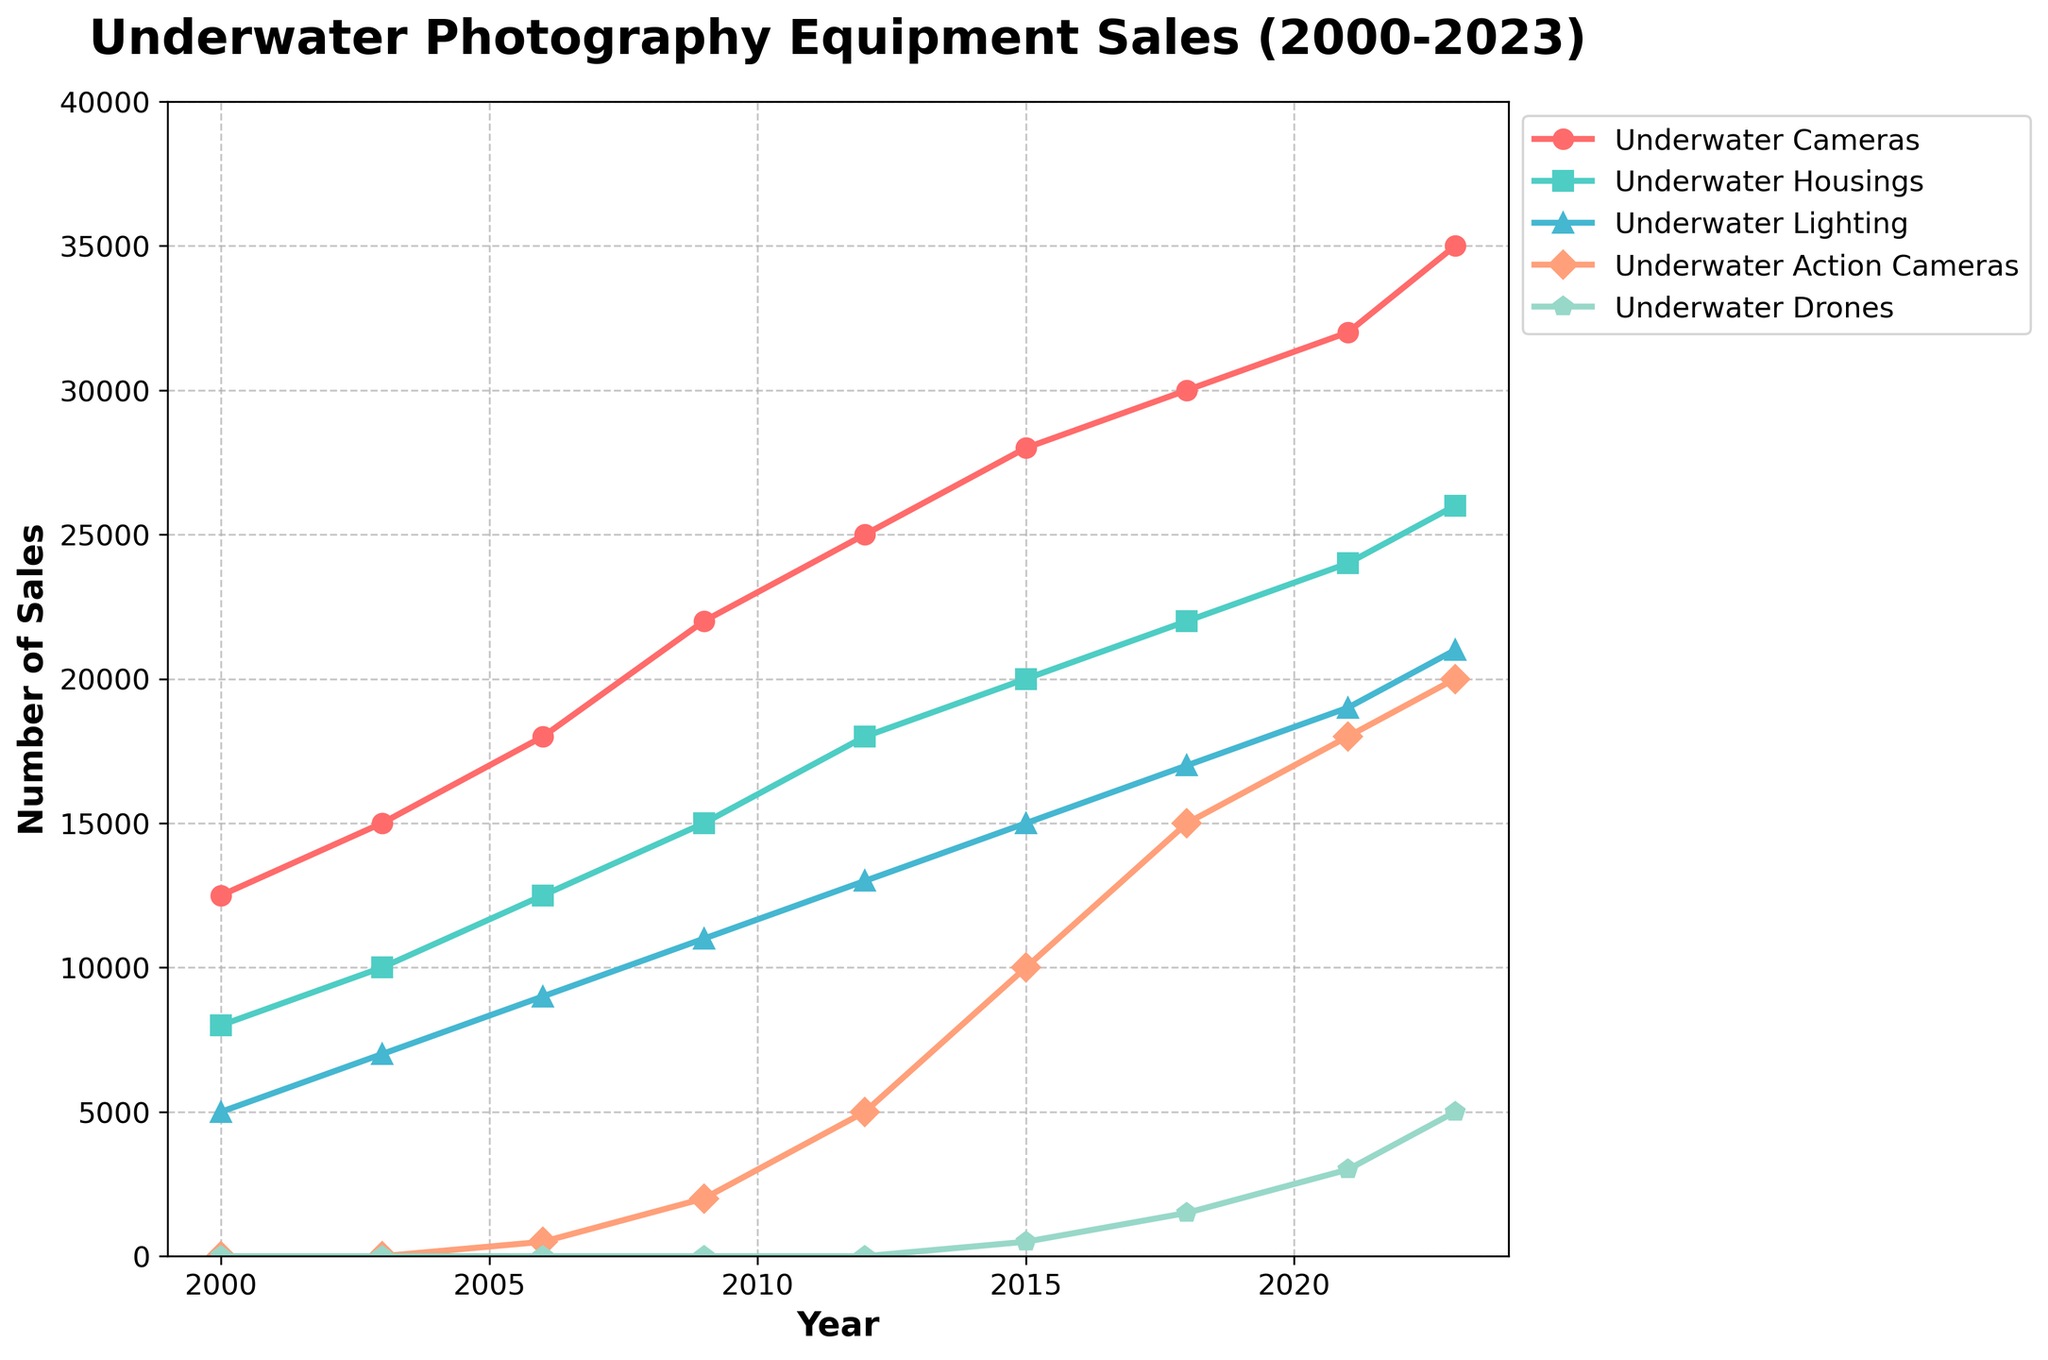What was the total number of underwater photography equipment sales in 2023? Sum up the sales for each type of equipment in 2023: 35000 (Underwater Cameras) + 26000 (Underwater Housings) + 21000 (Underwater Lighting) + 20000 (Underwater Action Cameras) + 5000 (Underwater Drones). The total is 107000.
Answer: 107000 Which type of equipment had the highest sales in 2023? Look at the sales numbers for each type of equipment in 2023. Underwater Cameras have the highest sales at 35000.
Answer: Underwater Cameras How much did the sales of Underwater Action Cameras increase from 2006 to 2023? Subtract the sales in 2006 from the sales in 2023 for Underwater Action Cameras: 20000 (2023) - 500 (2006). The increase is 19500.
Answer: 19500 Which type of equipment showed the most consistent increase in sales from 2000 to 2023? Observe the trends for all types of equipment from 2000 to 2023. Underwater Cameras show a consistent increase without any dips in sales.
Answer: Underwater Cameras What is the average number of Underwater Lighting equipment sales from 2000 to 2023? Add the sales for Underwater Lighting over the years and divide by the number of years recorded: (5000 + 7000 + 9000 + 11000 + 13000 + 15000 + 17000 + 19000 + 21000) / 9. The average is 13000.
Answer: 13000 Which year first saw sales of Underwater Drones? Look at the sales data for Underwater Drones. The first year with non-zero sales is 2015 with 500 units sold.
Answer: 2015 In which year did Underwater Housings sales reach 20000? Check the sales for Underwater Housings. In 2015, the sales were exactly 20000.
Answer: 2015 How did the sales of Underwater Cameras change from 2000 to 2023? Subtract the sales in 2000 from the sales in 2023 for Underwater Cameras: 35000 (2023) - 12500 (2000). The increase is 22500.
Answer: 22500 Compare the growth in sales of Underwater Action Cameras and Underwater Drones from 2015 to 2023. Which had higher growth? Calculate the growth for both types: Underwater Action Cameras: 20000 (2023) - 10000 (2015) = 10000. Underwater Drones: 5000 (2023) - 500 (2015) = 4500. Underwater Action Cameras had higher growth at 10000.
Answer: Underwater Action Cameras What was the largest single-year increase in Underwater Lighting sales? Check the incremental increase year by year for Underwater Lighting. The largest single-year increase was between 2000 (5000) and 2003 (7000), which is an increase of 2000 sales.
Answer: 2000 